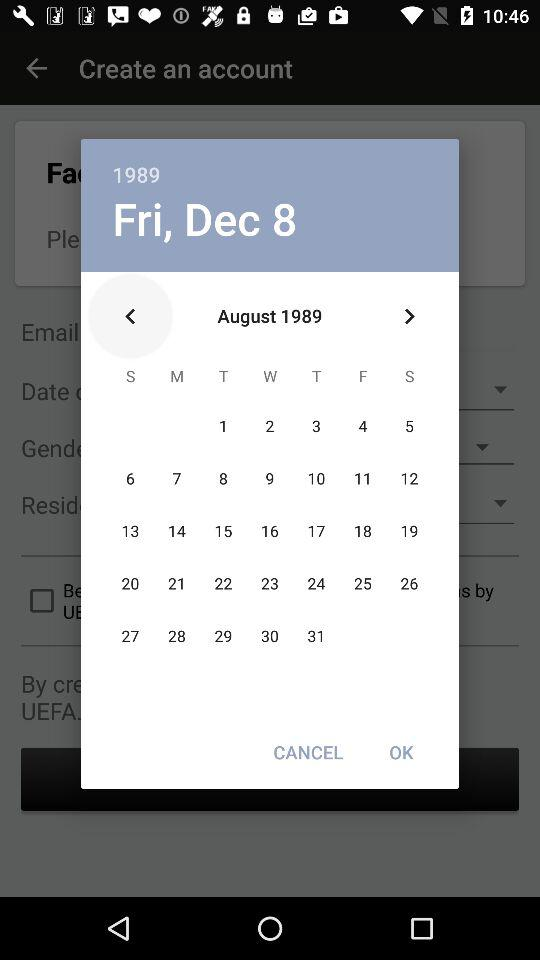What is the date? The date is Friday, December 8, 1989. 